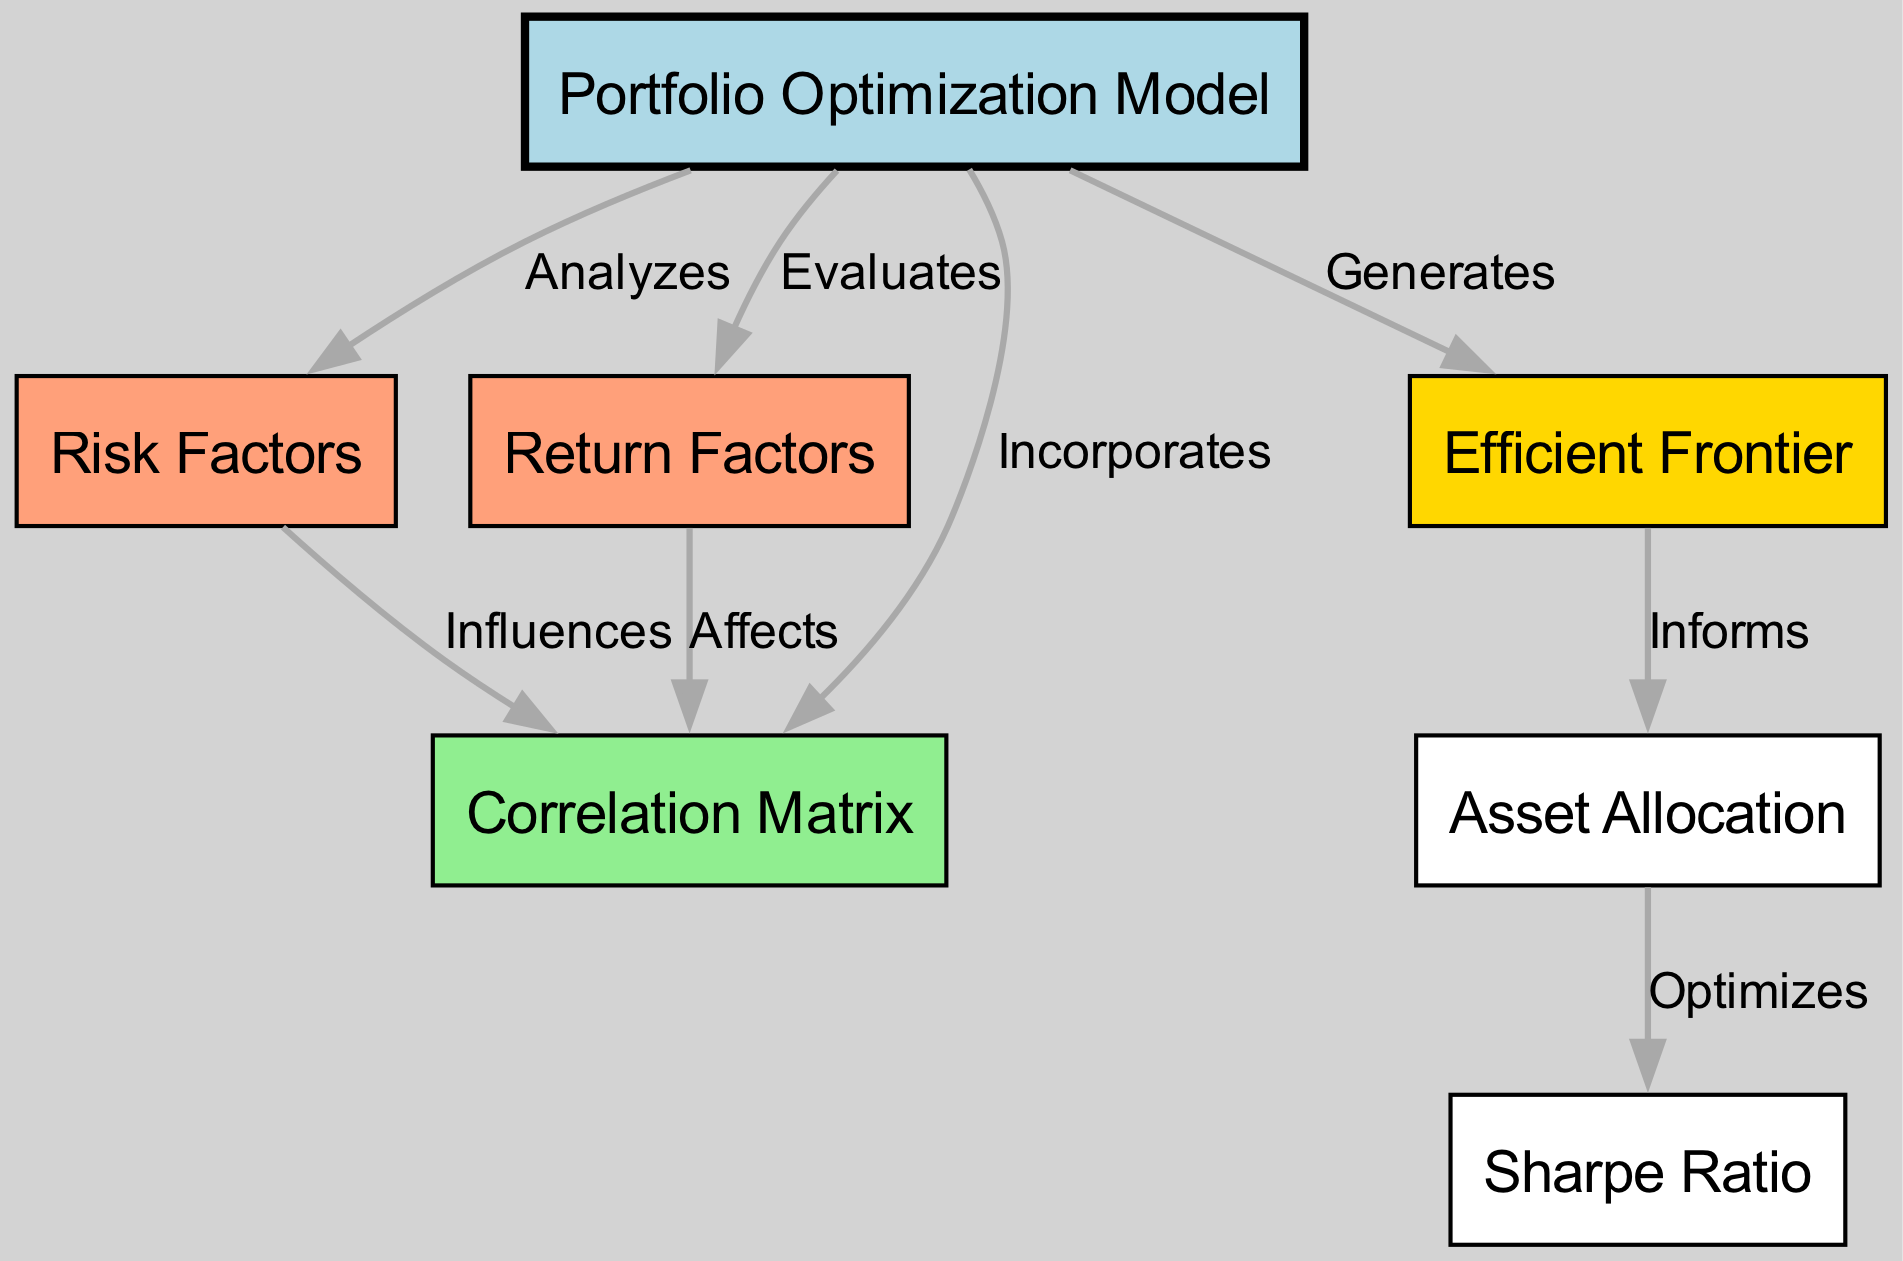What is the total number of nodes in the diagram? The diagram features 7 different nodes representing various components of the portfolio optimization model. Each node is identified distinctly by its unique ID, and the list of nodes confirms this total count.
Answer: 7 Which node generates the Efficient Frontier? In the diagram, there is a directed edge that indicates the Portfolio Optimization Model (node 1) generates the Efficient Frontier (node 5). This relationship denotes that node 1 produces the results represented by node 5.
Answer: Efficient Frontier What influences the Correlation Matrix? The nodes that influence the Correlation Matrix (node 4) are the Risk Factors (node 2) and the Return Factors (node 3). The diagram shows directed edges from both node 2 and node 3 pointing towards node 4, signifying their influence on it.
Answer: Risk Factors and Return Factors What does Asset Allocation optimize? The diagram indicates that Asset Allocation (node 6) optimizes the Sharpe Ratio (node 7). The directed edge from node 6 to node 7 illustrates that the process of asset allocation directly leads to the optimization of the Sharpe Ratio.
Answer: Sharpe Ratio How many edges connect the nodes in the diagram? By counting the directed edges illustrated in the diagram, there is a total of 8 edges that connect the various nodes. Each edge represents the relationship or interaction between two nodes.
Answer: 8 What relationship does Return Factors have with Correlation Matrix? The diagram indicates that Return Factors (node 3) affects the Correlation Matrix (node 4). This is indicated by a directed edge leading from node 3 to node 4, showing that changes in return factors can impact the correlation matrix outcomes.
Answer: Affects Which node analyzes Risk Factors? The diagram specifies that the Portfolio Optimization Model (node 1) analyzes the Risk Factors (node 2). This relationship is represented by a directed edge from node 1 to node 2, showing that the optimization model takes Risk Factors into account.
Answer: Portfolio Optimization Model 